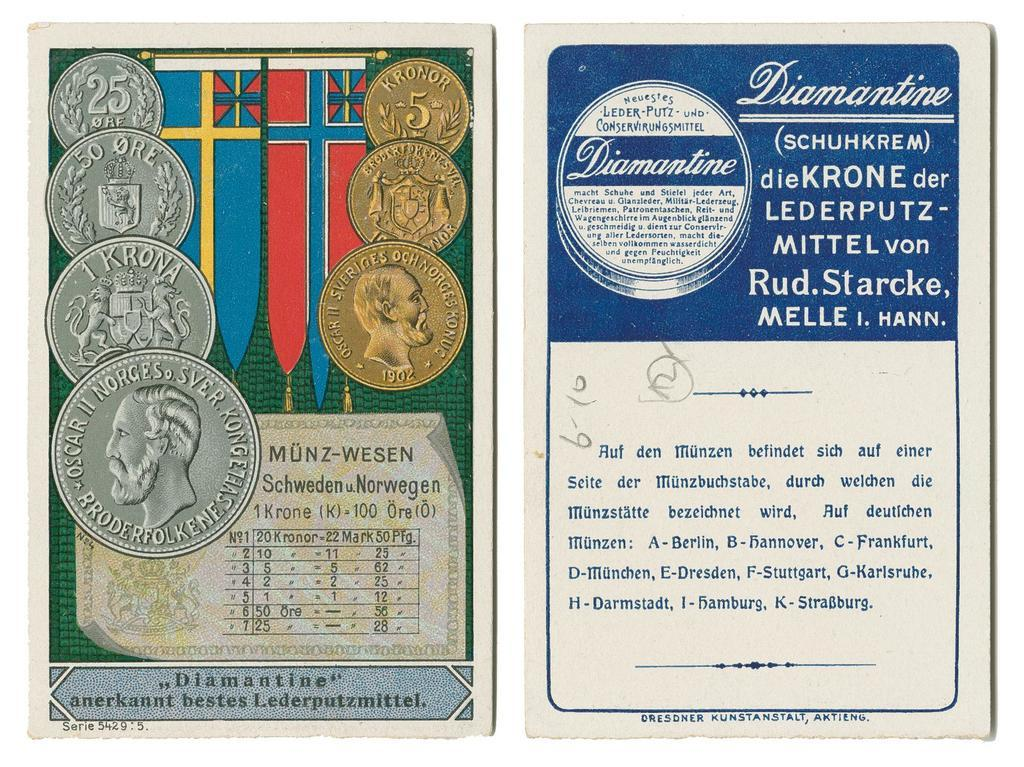<image>
Present a compact description of the photo's key features. Gold and Silver coins with 1 Krona imprinted on the 3 coin on the left. 